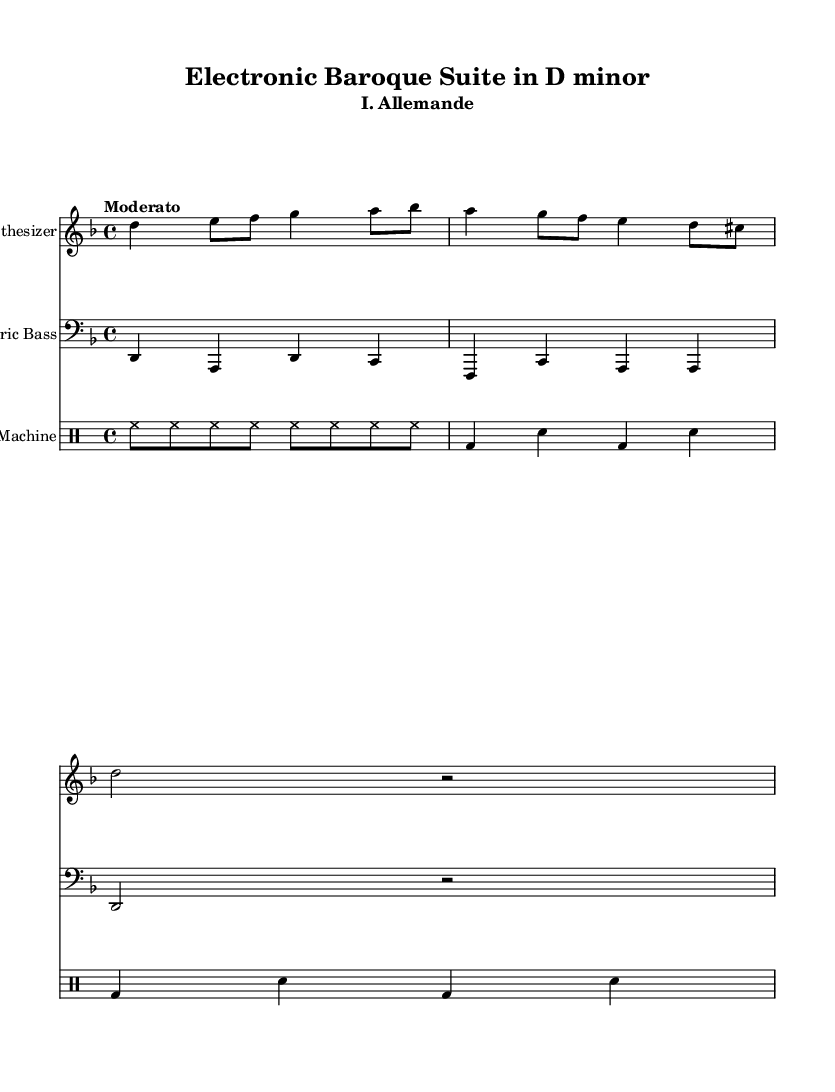What is the key signature of this music? The key signature indicates that the piece is in D minor, which has one flat (B flat) in its key signature. This can be identified by looking at the key signature section at the beginning of the music.
Answer: D minor What is the time signature of this music? The time signature displayed at the beginning of the sheet music shows 4/4, meaning there are four beats per measure and the quarter note receives one beat. This is visibly noted in the time signature section.
Answer: 4/4 What is the tempo marking for this piece? The tempo marking "Moderato" indicates that the piece should be played at a moderate speed. This can be found at the top of the sheet music under the global settings.
Answer: Moderato How many measures are there in the synthesizer part? Counting the measures in the synthesized music section reveals that there are a total of three measures. Each measure is separated by vertical lines, making it easy to count.
Answer: Three What rhythmic pattern is predominant in the drum machine part? The drum machine part primarily features a consistent pattern of hi-hats followed by a varied kick and snare drum pattern. This indicates a common rhythmic structure, often used in electronic music for steady accompaniment.
Answer: Hi-hat pattern How does the electric bass complement the synthesizer in terms of harmony? The electric bass largely follows the fundamental notes of the synthesizer's line, providing a harmonic foundation which supports the melodic content. The bass notes correspond to the root notes of the chords suggested by the synthesizer melody.
Answer: Root notes 